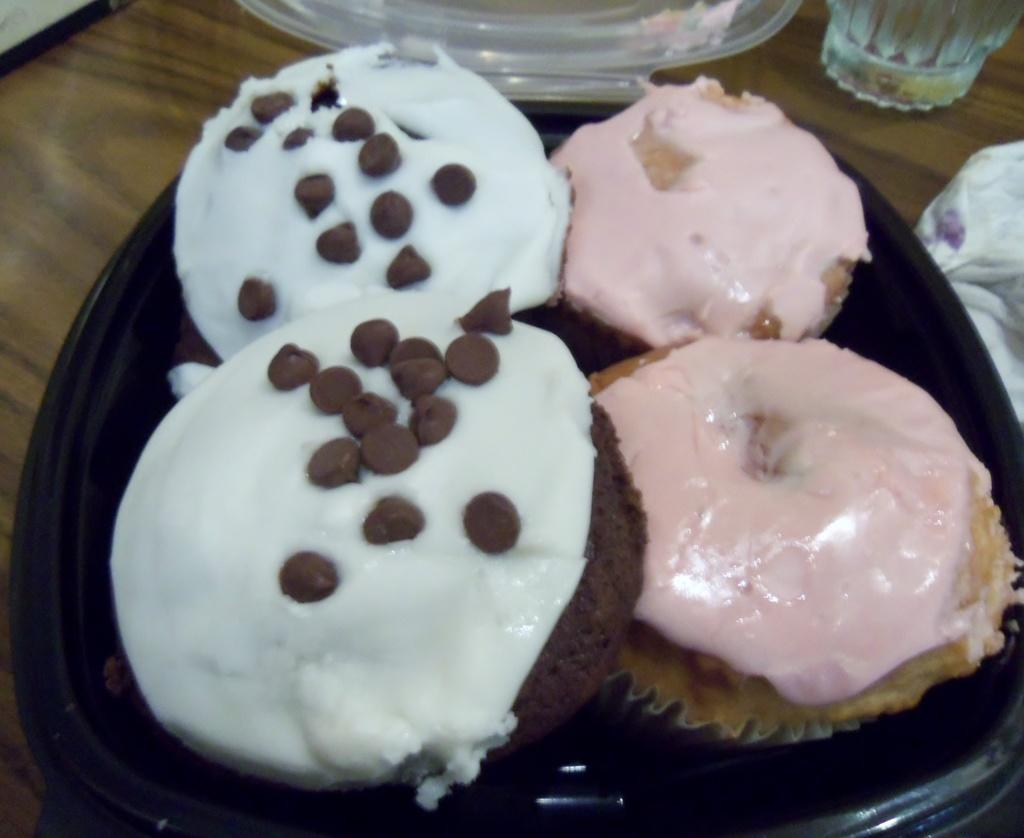What type of food items can be seen in the image? There are food items in a bowl in the image. What material are the objects visible in the image made of? There are glass objects visible in the image. Where is the object located in the image? The object is on a wooden surface. What type of button can be seen on the front of the object in the image? There is no button visible on the object in the image. 